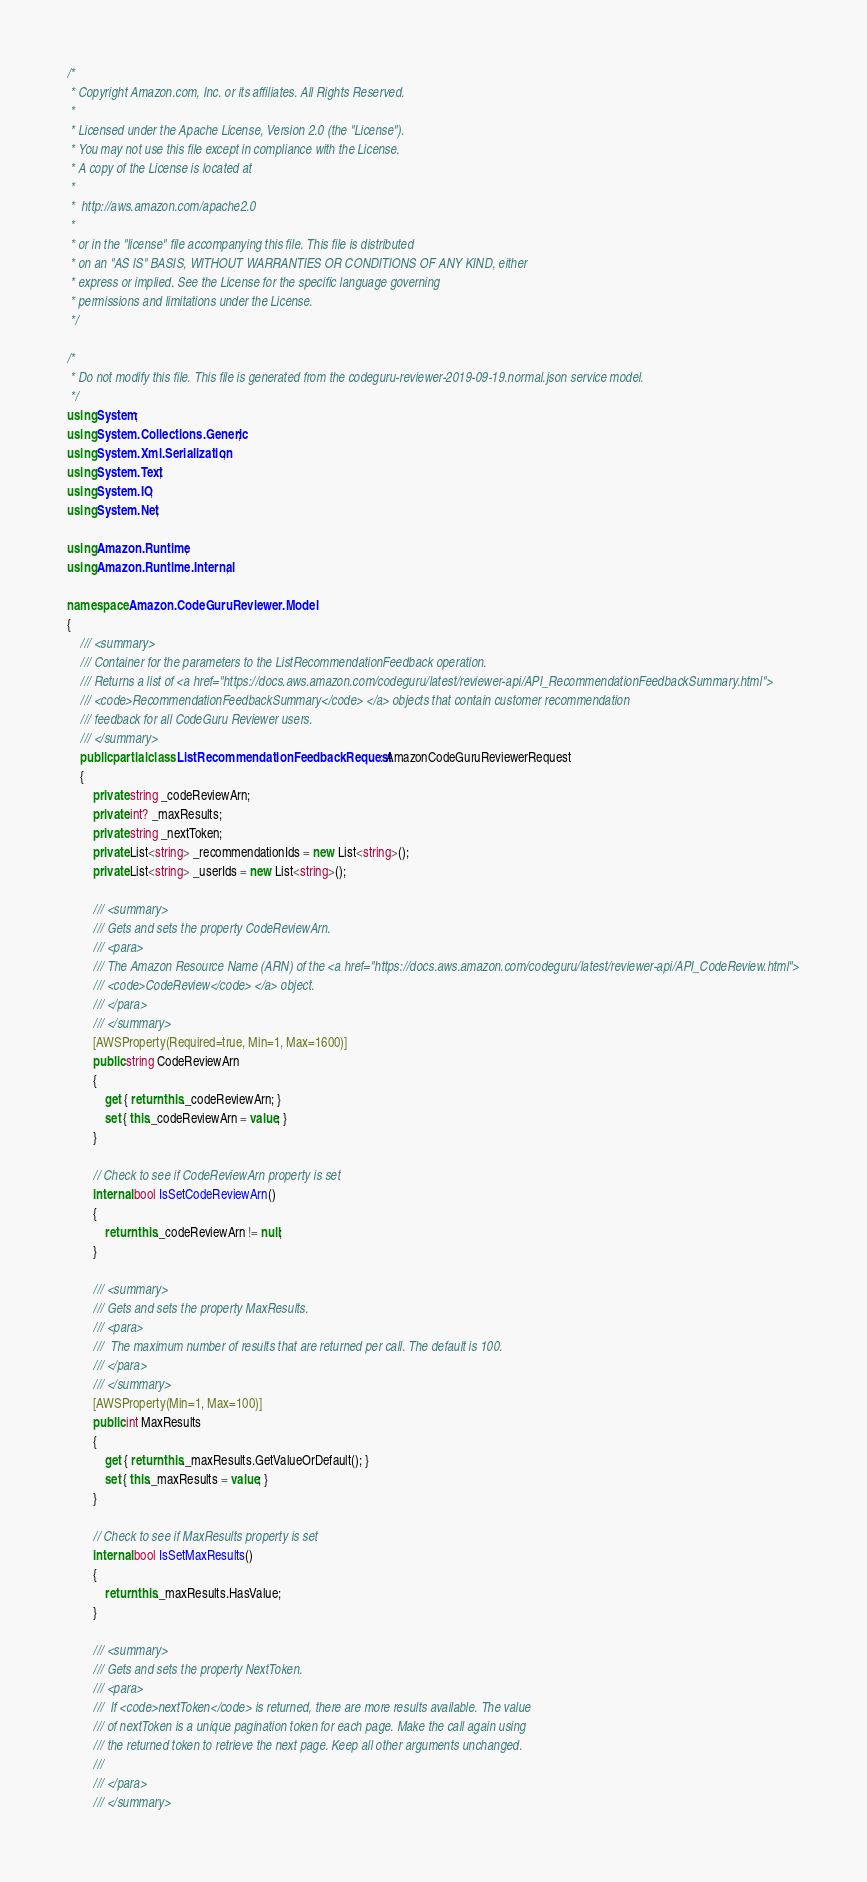<code> <loc_0><loc_0><loc_500><loc_500><_C#_>/*
 * Copyright Amazon.com, Inc. or its affiliates. All Rights Reserved.
 * 
 * Licensed under the Apache License, Version 2.0 (the "License").
 * You may not use this file except in compliance with the License.
 * A copy of the License is located at
 * 
 *  http://aws.amazon.com/apache2.0
 * 
 * or in the "license" file accompanying this file. This file is distributed
 * on an "AS IS" BASIS, WITHOUT WARRANTIES OR CONDITIONS OF ANY KIND, either
 * express or implied. See the License for the specific language governing
 * permissions and limitations under the License.
 */

/*
 * Do not modify this file. This file is generated from the codeguru-reviewer-2019-09-19.normal.json service model.
 */
using System;
using System.Collections.Generic;
using System.Xml.Serialization;
using System.Text;
using System.IO;
using System.Net;

using Amazon.Runtime;
using Amazon.Runtime.Internal;

namespace Amazon.CodeGuruReviewer.Model
{
    /// <summary>
    /// Container for the parameters to the ListRecommendationFeedback operation.
    /// Returns a list of <a href="https://docs.aws.amazon.com/codeguru/latest/reviewer-api/API_RecommendationFeedbackSummary.html">
    /// <code>RecommendationFeedbackSummary</code> </a> objects that contain customer recommendation
    /// feedback for all CodeGuru Reviewer users.
    /// </summary>
    public partial class ListRecommendationFeedbackRequest : AmazonCodeGuruReviewerRequest
    {
        private string _codeReviewArn;
        private int? _maxResults;
        private string _nextToken;
        private List<string> _recommendationIds = new List<string>();
        private List<string> _userIds = new List<string>();

        /// <summary>
        /// Gets and sets the property CodeReviewArn. 
        /// <para>
        /// The Amazon Resource Name (ARN) of the <a href="https://docs.aws.amazon.com/codeguru/latest/reviewer-api/API_CodeReview.html">
        /// <code>CodeReview</code> </a> object. 
        /// </para>
        /// </summary>
        [AWSProperty(Required=true, Min=1, Max=1600)]
        public string CodeReviewArn
        {
            get { return this._codeReviewArn; }
            set { this._codeReviewArn = value; }
        }

        // Check to see if CodeReviewArn property is set
        internal bool IsSetCodeReviewArn()
        {
            return this._codeReviewArn != null;
        }

        /// <summary>
        /// Gets and sets the property MaxResults. 
        /// <para>
        ///  The maximum number of results that are returned per call. The default is 100. 
        /// </para>
        /// </summary>
        [AWSProperty(Min=1, Max=100)]
        public int MaxResults
        {
            get { return this._maxResults.GetValueOrDefault(); }
            set { this._maxResults = value; }
        }

        // Check to see if MaxResults property is set
        internal bool IsSetMaxResults()
        {
            return this._maxResults.HasValue; 
        }

        /// <summary>
        /// Gets and sets the property NextToken. 
        /// <para>
        ///  If <code>nextToken</code> is returned, there are more results available. The value
        /// of nextToken is a unique pagination token for each page. Make the call again using
        /// the returned token to retrieve the next page. Keep all other arguments unchanged.
        /// 
        /// </para>
        /// </summary></code> 